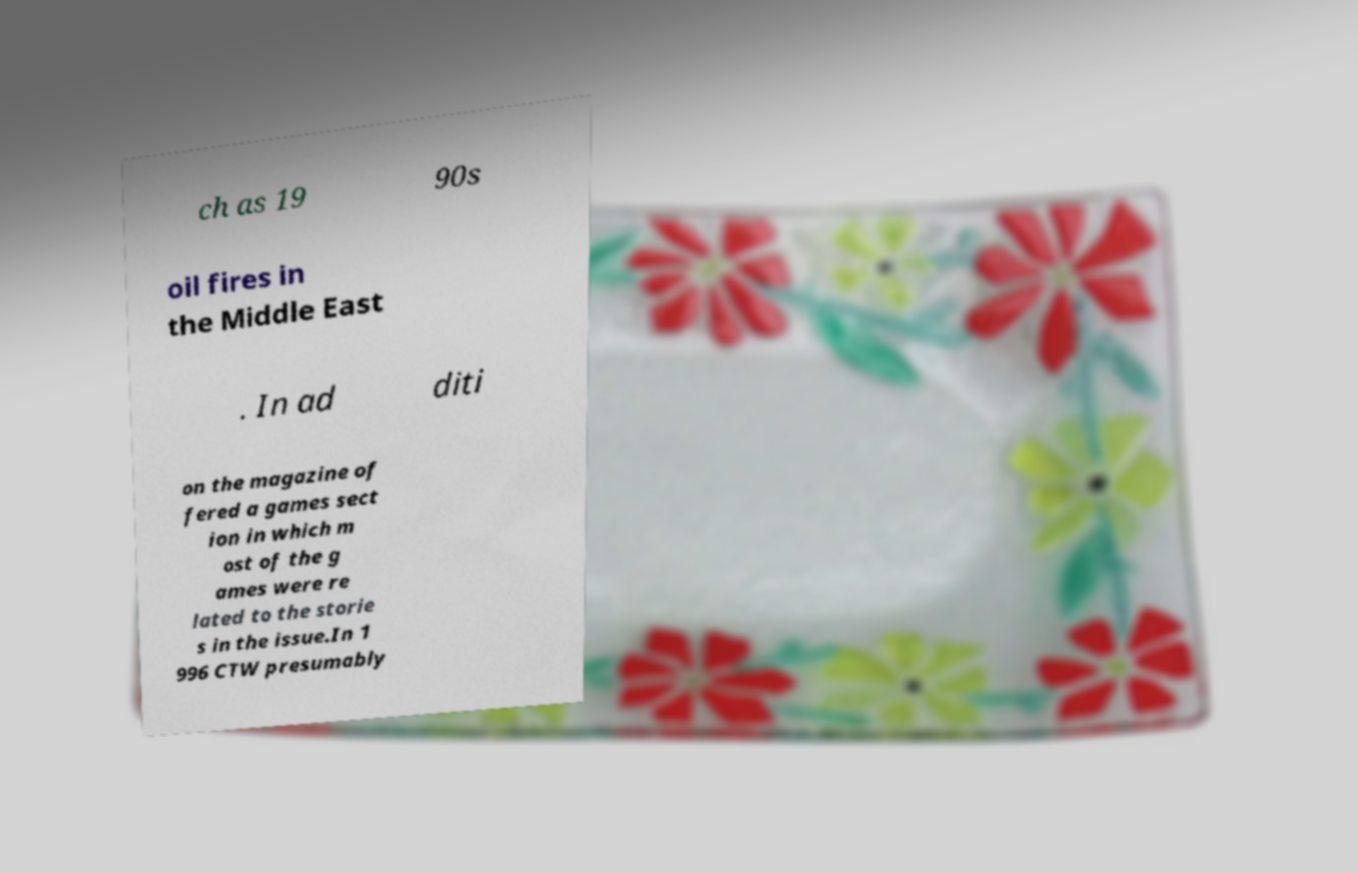What messages or text are displayed in this image? I need them in a readable, typed format. ch as 19 90s oil fires in the Middle East . In ad diti on the magazine of fered a games sect ion in which m ost of the g ames were re lated to the storie s in the issue.In 1 996 CTW presumably 